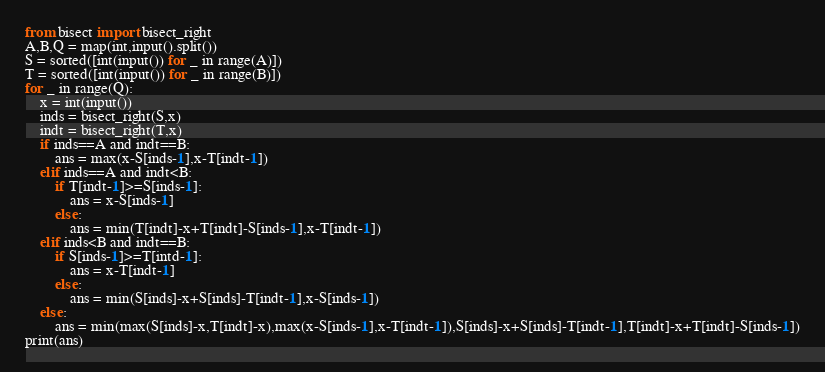<code> <loc_0><loc_0><loc_500><loc_500><_Python_>from bisect import bisect_right
A,B,Q = map(int,input().split())
S = sorted([int(input()) for _ in range(A)])
T = sorted([int(input()) for _ in range(B)])
for _ in range(Q):
    x = int(input())
    inds = bisect_right(S,x)
    indt = bisect_right(T,x)
    if inds==A and indt==B:
        ans = max(x-S[inds-1],x-T[indt-1])
    elif inds==A and indt<B:
        if T[indt-1]>=S[inds-1]:
            ans = x-S[inds-1]
        else:
            ans = min(T[indt]-x+T[indt]-S[inds-1],x-T[indt-1])
    elif inds<B and indt==B:
        if S[inds-1]>=T[intd-1]:
            ans = x-T[indt-1]
        else:
            ans = min(S[inds]-x+S[inds]-T[indt-1],x-S[inds-1])
    else:
        ans = min(max(S[inds]-x,T[indt]-x),max(x-S[inds-1],x-T[indt-1]),S[inds]-x+S[inds]-T[indt-1],T[indt]-x+T[indt]-S[inds-1])
print(ans)</code> 